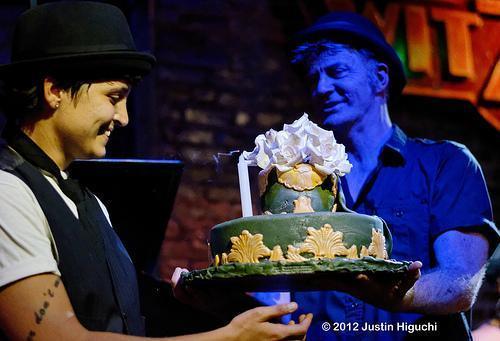How many people are there?
Give a very brief answer. 2. 